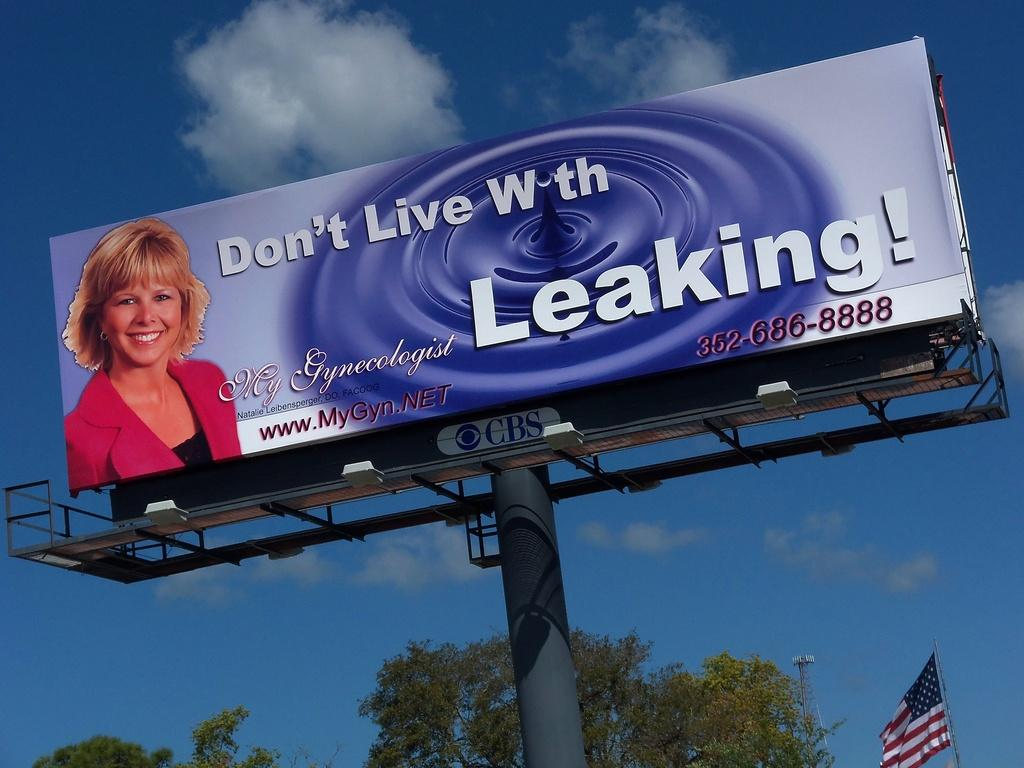<image>
Summarize the visual content of the image. A billboard shows a woman on the left and Leaking on the right side. 